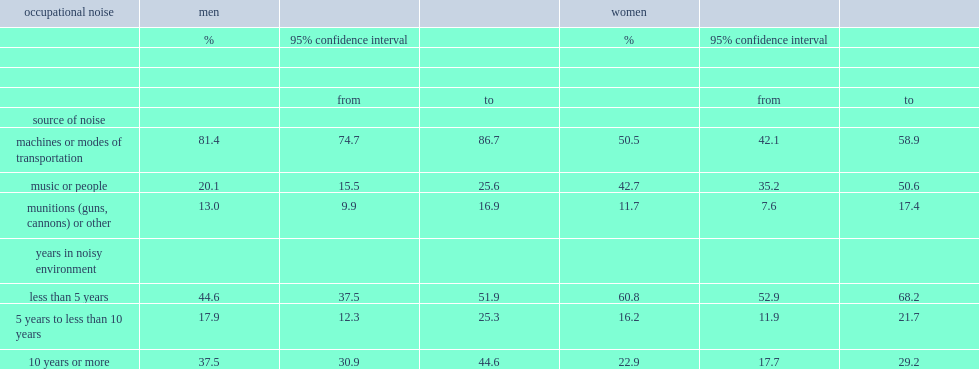Which sex is more likely to identify machinery and modes of transportation as the sources of loud workplace noise among vulnerable workers, men or women? Men. What is the percentage of men identify machinery and modes of transportation as the sources of loud workplace noise among vulnerable workers? 81.4. What is the percentage of women identify machinery and modes of transportation as the sources of loud workplace noise among vulnerable workers? 50.5. Which sex is more likely to experience loud workplace noise caused by amplified music and noise from people, men or women? Women. What is the percentage of women experience loud workplace noise caused by amplified music and noise from people? 42.7. What is the percentage of men experience loud workplace noise caused by amplified music and noise from people? 20.1. How many years have most vulnerable women worked in noisy environments? Less than 5 years. What is the percentage of men working in noisy environments for less than five years? 44.6. Which sex is more likely to have worked in noisy environments for 10 years or more, men or women? Men. What is the percentage of vulnerable men having worked in noisy environments for 10 years or more? 37.5. What is the percentage of vulnerable men having worked in noisy environments for 10 years or more? 22.9. 